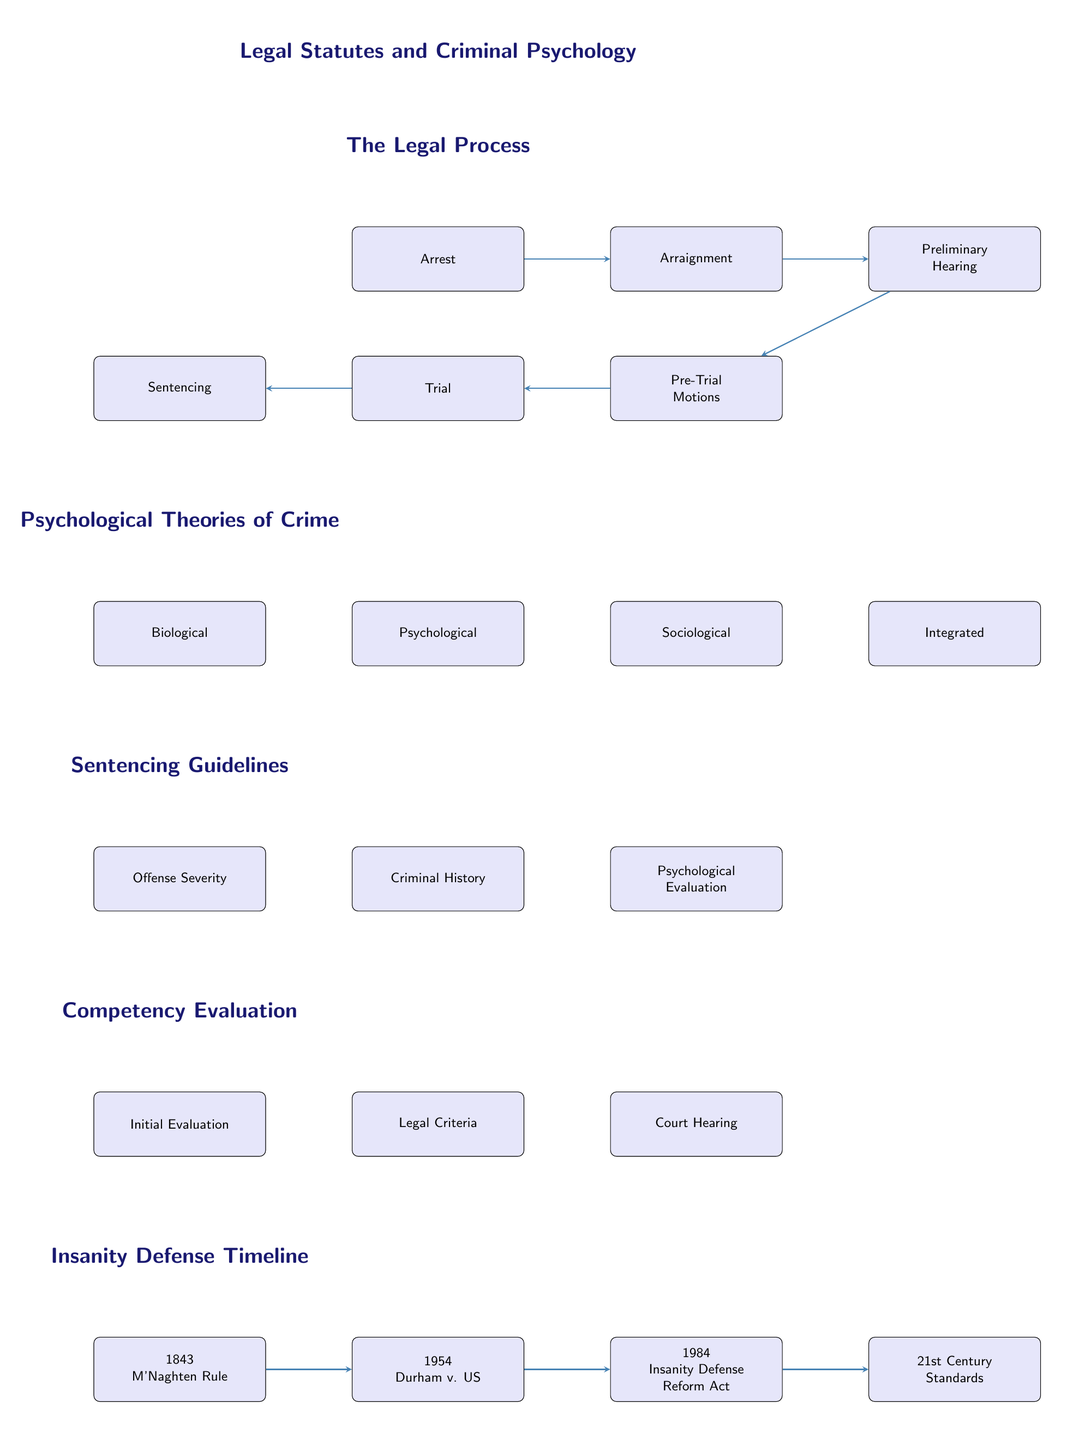What stage follows the Arrest? The diagram shows that the next stage after Arrest is Arraignment, as represented by the arrow connecting them.
Answer: Arraignment How many stages are in the legal process? Counting the boxes in the Legal Process section reveals six stages: Arrest, Arraignment, Preliminary Hearing, Pre-Trial Motions, Trial, and Sentencing.
Answer: Six What are the four psychological theories of crime listed in the diagram? The diagram presents four theories: Biological, Psychological, Sociological, and Integrated.
Answer: Biological, Psychological, Sociological, Integrated Which stage directly precedes the Trial? By examining the flow of the diagram, it is clear that the stage that comes directly before the Trial is the Pre-Trial Motions.
Answer: Pre-Trial Motions What is the first step in the Competency Evaluation? According to the diagram, the first step is the Initial Evaluation, indicated by its placement at the top of the Competency Evaluation section.
Answer: Initial Evaluation Which psychological factor is part of the Sentencing Guidelines? The diagram shows that Psychological Evaluation is one of the factors considered during Sentencing, adjacent to Offense Severity and Criminal History.
Answer: Psychological Evaluation What does the decision tree in the Competency Evaluation assess? The flow of the Competency Evaluation section indicates that it assesses Legal Criteria and proceeds to a Court Hearing if conditions are met.
Answer: Legal Criteria What significant legal case is represented in the timeline for the Insanity Defense? The diagram highlights the 1954 case of Durham v. US as a significant point in the timeline of the Insanity Defense.
Answer: Durham v. US What led from the M'Naghten Rule to the Durham case? The timeline in the diagram shows that the M'Naghten Rule in 1843 led to the next arrow pointing towards the 1954 Durham case, indicating a chronological progression of legal understanding.
Answer: M'Naghten Rule Which assessment is NOT part of the Sentencing Guidelines? Reviewing the diagram, one can see that a factor such as Offense Severity, Criminal History, and Psychological Evaluation are included, but there are no references to victim impact statements or external factors.
Answer: Victim impact statements 